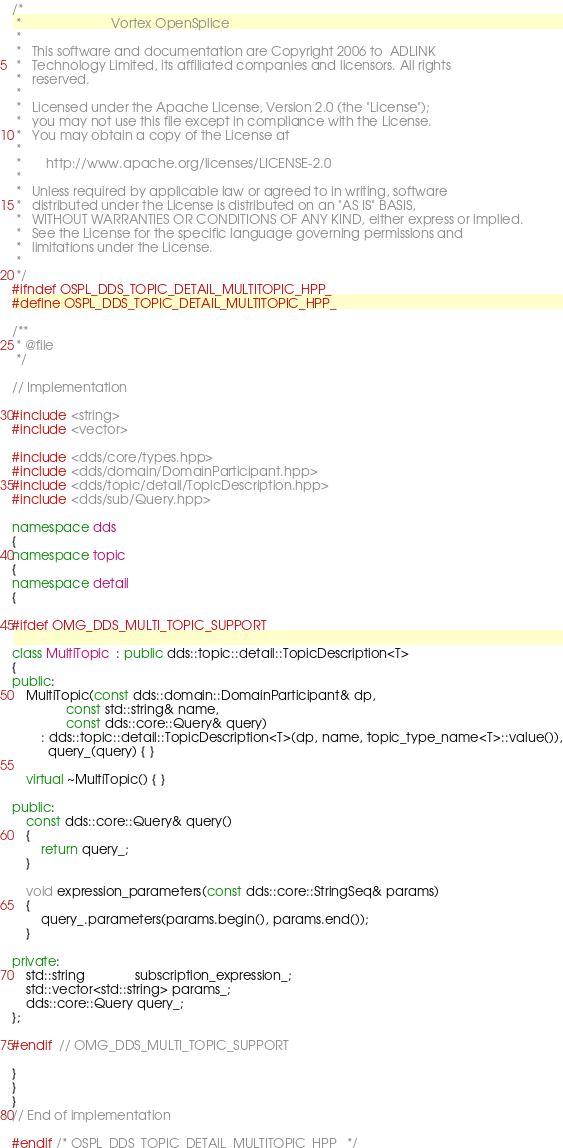<code> <loc_0><loc_0><loc_500><loc_500><_C++_>/*
 *                         Vortex OpenSplice
 *
 *   This software and documentation are Copyright 2006 to  ADLINK
 *   Technology Limited, its affiliated companies and licensors. All rights
 *   reserved.
 *
 *   Licensed under the Apache License, Version 2.0 (the "License");
 *   you may not use this file except in compliance with the License.
 *   You may obtain a copy of the License at
 *
 *       http://www.apache.org/licenses/LICENSE-2.0
 *
 *   Unless required by applicable law or agreed to in writing, software
 *   distributed under the License is distributed on an "AS IS" BASIS,
 *   WITHOUT WARRANTIES OR CONDITIONS OF ANY KIND, either express or implied.
 *   See the License for the specific language governing permissions and
 *   limitations under the License.
 *
 */
#ifndef OSPL_DDS_TOPIC_DETAIL_MULTITOPIC_HPP_
#define OSPL_DDS_TOPIC_DETAIL_MULTITOPIC_HPP_

/**
 * @file
 */

// Implementation

#include <string>
#include <vector>

#include <dds/core/types.hpp>
#include <dds/domain/DomainParticipant.hpp>
#include <dds/topic/detail/TopicDescription.hpp>
#include <dds/sub/Query.hpp>

namespace dds
{
namespace topic
{
namespace detail
{

#ifdef OMG_DDS_MULTI_TOPIC_SUPPORT

class MultiTopic  : public dds::topic::detail::TopicDescription<T>
{
public:
    MultiTopic(const dds::domain::DomainParticipant& dp,
               const std::string& name,
               const dds::core::Query& query)
        : dds::topic::detail::TopicDescription<T>(dp, name, topic_type_name<T>::value()),
          query_(query) { }

    virtual ~MultiTopic() { }

public:
    const dds::core::Query& query()
    {
        return query_;
    }

    void expression_parameters(const dds::core::StringSeq& params)
    {
        query_.parameters(params.begin(), params.end());
    }

private:
    std::string              subscription_expression_;
    std::vector<std::string> params_;
    dds::core::Query query_;
};

#endif  // OMG_DDS_MULTI_TOPIC_SUPPORT

}
}
}
// End of implementation

#endif /* OSPL_DDS_TOPIC_DETAIL_MULTITOPIC_HPP_ */
</code> 